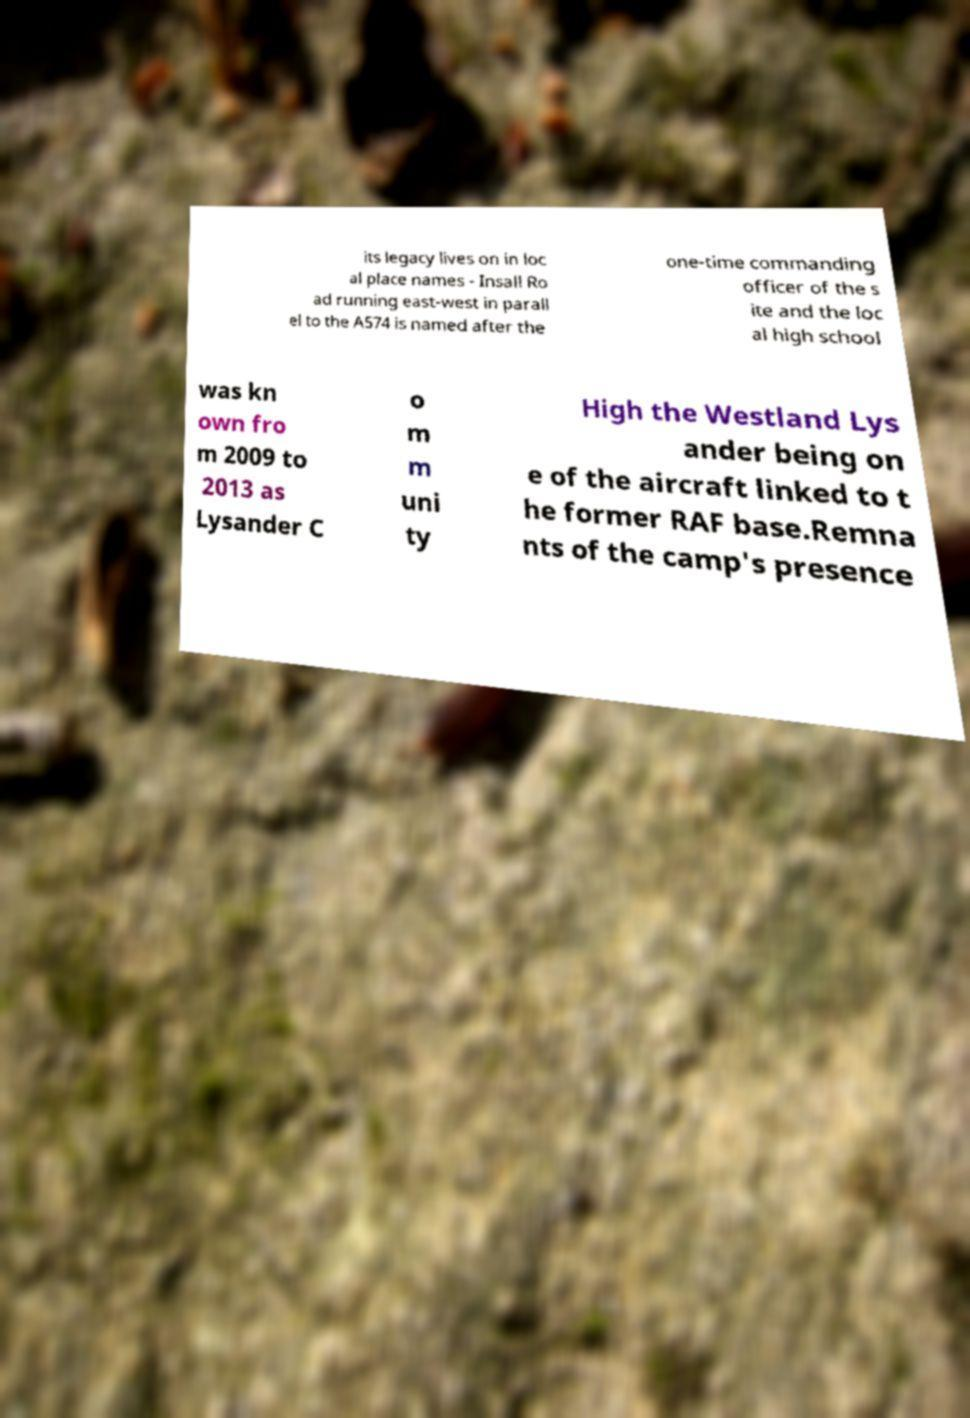Please read and relay the text visible in this image. What does it say? its legacy lives on in loc al place names - Insall Ro ad running east-west in parall el to the A574 is named after the one-time commanding officer of the s ite and the loc al high school was kn own fro m 2009 to 2013 as Lysander C o m m uni ty High the Westland Lys ander being on e of the aircraft linked to t he former RAF base.Remna nts of the camp's presence 